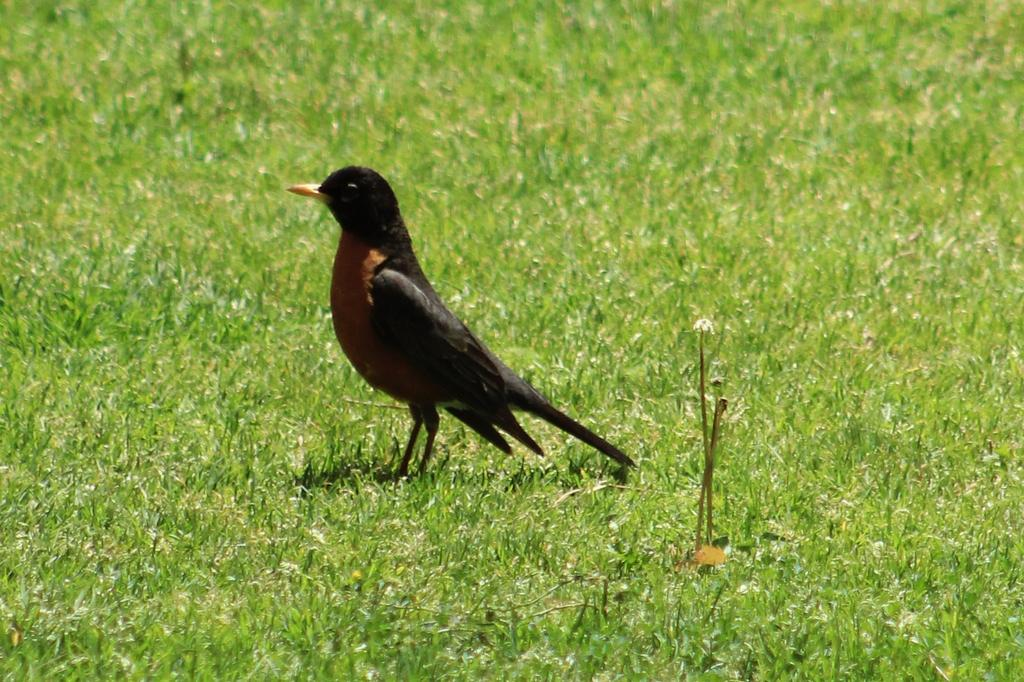Who is present in the image? There is a man in the image. What is the man's position in relation to the ground? The man is standing on the ground. Is the man's mind visible in the image? The man's mind is not visible in the image, as it is an abstract concept and not something that can be seen. 